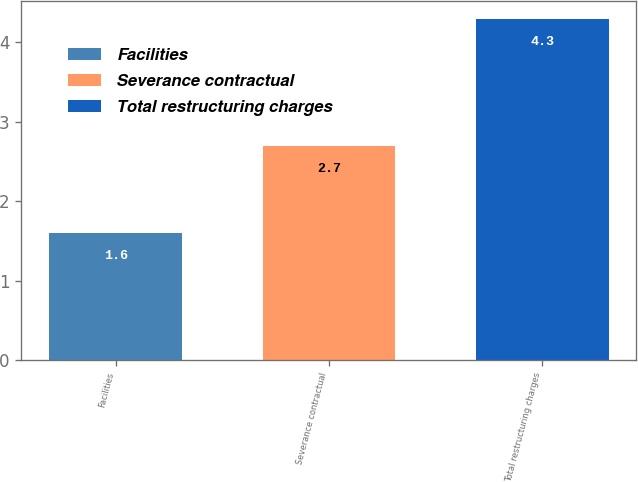Convert chart to OTSL. <chart><loc_0><loc_0><loc_500><loc_500><bar_chart><fcel>Facilities<fcel>Severance contractual<fcel>Total restructuring charges<nl><fcel>1.6<fcel>2.7<fcel>4.3<nl></chart> 